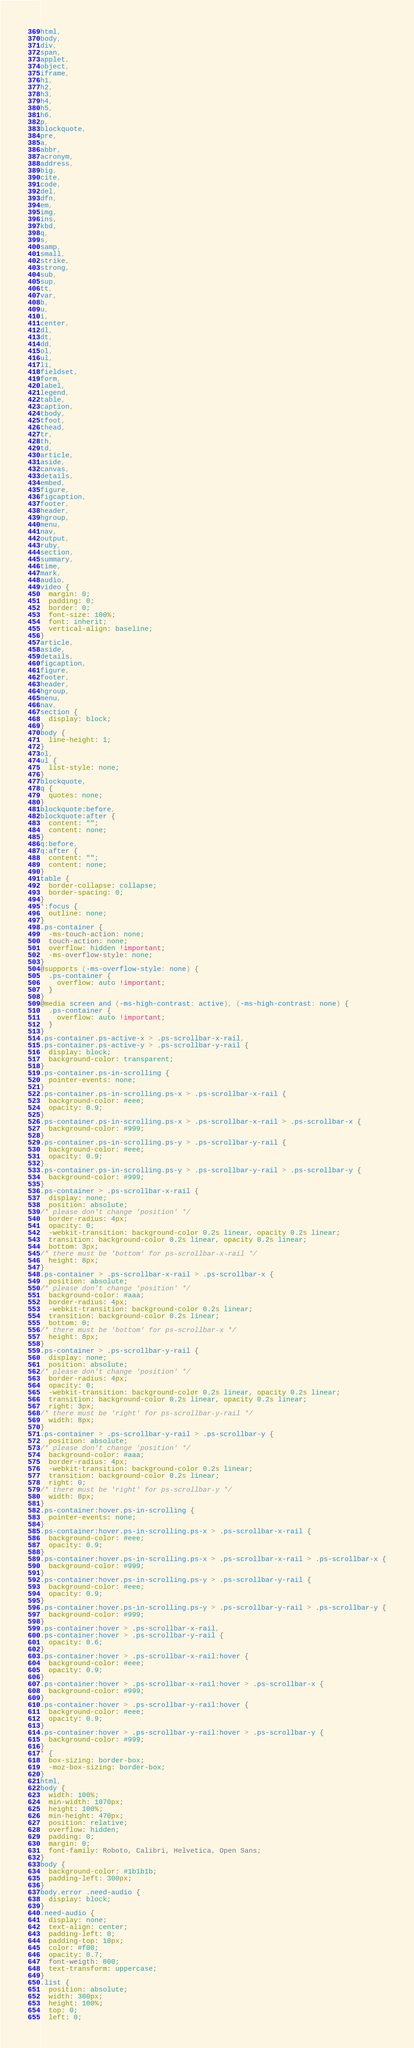Convert code to text. <code><loc_0><loc_0><loc_500><loc_500><_CSS_>html,
body,
div,
span,
applet,
object,
iframe,
h1,
h2,
h3,
h4,
h5,
h6,
p,
blockquote,
pre,
a,
abbr,
acronym,
address,
big,
cite,
code,
del,
dfn,
em,
img,
ins,
kbd,
q,
s,
samp,
small,
strike,
strong,
sub,
sup,
tt,
var,
b,
u,
i,
center,
dl,
dt,
dd,
ol,
ul,
li,
fieldset,
form,
label,
legend,
table,
caption,
tbody,
tfoot,
thead,
tr,
th,
td,
article,
aside,
canvas,
details,
embed,
figure,
figcaption,
footer,
header,
hgroup,
menu,
nav,
output,
ruby,
section,
summary,
time,
mark,
audio,
video {
  margin: 0;
  padding: 0;
  border: 0;
  font-size: 100%;
  font: inherit;
  vertical-align: baseline;
}
article,
aside,
details,
figcaption,
figure,
footer,
header,
hgroup,
menu,
nav,
section {
  display: block;
}
body {
  line-height: 1;
}
ol,
ul {
  list-style: none;
}
blockquote,
q {
  quotes: none;
}
blockquote:before,
blockquote:after {
  content: "";
  content: none;
}
q:before,
q:after {
  content: "";
  content: none;
}
table {
  border-collapse: collapse;
  border-spacing: 0;
}
*:focus {
  outline: none;
}
.ps-container {
  -ms-touch-action: none;
  touch-action: none;
  overflow: hidden !important;
  -ms-overflow-style: none;
}
@supports (-ms-overflow-style: none) {
  .ps-container {
    overflow: auto !important;
  }
}
@media screen and (-ms-high-contrast: active), (-ms-high-contrast: none) {
  .ps-container {
    overflow: auto !important;
  }
}
.ps-container.ps-active-x > .ps-scrollbar-x-rail,
.ps-container.ps-active-y > .ps-scrollbar-y-rail {
  display: block;
  background-color: transparent;
}
.ps-container.ps-in-scrolling {
  pointer-events: none;
}
.ps-container.ps-in-scrolling.ps-x > .ps-scrollbar-x-rail {
  background-color: #eee;
  opacity: 0.9;
}
.ps-container.ps-in-scrolling.ps-x > .ps-scrollbar-x-rail > .ps-scrollbar-x {
  background-color: #999;
}
.ps-container.ps-in-scrolling.ps-y > .ps-scrollbar-y-rail {
  background-color: #eee;
  opacity: 0.9;
}
.ps-container.ps-in-scrolling.ps-y > .ps-scrollbar-y-rail > .ps-scrollbar-y {
  background-color: #999;
}
.ps-container > .ps-scrollbar-x-rail {
  display: none;
  position: absolute;
/* please don't change 'position' */
  border-radius: 4px;
  opacity: 0;
  -webkit-transition: background-color 0.2s linear, opacity 0.2s linear;
  transition: background-color 0.2s linear, opacity 0.2s linear;
  bottom: 3px;
/* there must be 'bottom' for ps-scrollbar-x-rail */
  height: 8px;
}
.ps-container > .ps-scrollbar-x-rail > .ps-scrollbar-x {
  position: absolute;
/* please don't change 'position' */
  background-color: #aaa;
  border-radius: 4px;
  -webkit-transition: background-color 0.2s linear;
  transition: background-color 0.2s linear;
  bottom: 0;
/* there must be 'bottom' for ps-scrollbar-x */
  height: 8px;
}
.ps-container > .ps-scrollbar-y-rail {
  display: none;
  position: absolute;
/* please don't change 'position' */
  border-radius: 4px;
  opacity: 0;
  -webkit-transition: background-color 0.2s linear, opacity 0.2s linear;
  transition: background-color 0.2s linear, opacity 0.2s linear;
  right: 3px;
/* there must be 'right' for ps-scrollbar-y-rail */
  width: 8px;
}
.ps-container > .ps-scrollbar-y-rail > .ps-scrollbar-y {
  position: absolute;
/* please don't change 'position' */
  background-color: #aaa;
  border-radius: 4px;
  -webkit-transition: background-color 0.2s linear;
  transition: background-color 0.2s linear;
  right: 0;
/* there must be 'right' for ps-scrollbar-y */
  width: 8px;
}
.ps-container:hover.ps-in-scrolling {
  pointer-events: none;
}
.ps-container:hover.ps-in-scrolling.ps-x > .ps-scrollbar-x-rail {
  background-color: #eee;
  opacity: 0.9;
}
.ps-container:hover.ps-in-scrolling.ps-x > .ps-scrollbar-x-rail > .ps-scrollbar-x {
  background-color: #999;
}
.ps-container:hover.ps-in-scrolling.ps-y > .ps-scrollbar-y-rail {
  background-color: #eee;
  opacity: 0.9;
}
.ps-container:hover.ps-in-scrolling.ps-y > .ps-scrollbar-y-rail > .ps-scrollbar-y {
  background-color: #999;
}
.ps-container:hover > .ps-scrollbar-x-rail,
.ps-container:hover > .ps-scrollbar-y-rail {
  opacity: 0.6;
}
.ps-container:hover > .ps-scrollbar-x-rail:hover {
  background-color: #eee;
  opacity: 0.9;
}
.ps-container:hover > .ps-scrollbar-x-rail:hover > .ps-scrollbar-x {
  background-color: #999;
}
.ps-container:hover > .ps-scrollbar-y-rail:hover {
  background-color: #eee;
  opacity: 0.9;
}
.ps-container:hover > .ps-scrollbar-y-rail:hover > .ps-scrollbar-y {
  background-color: #999;
}
* {
  box-sizing: border-box;
  -moz-box-sizing: border-box;
}
html,
body {
  width: 100%;
  min-width: 1070px;
  height: 100%;
  min-height: 470px;
  position: relative;
  overflow: hidden;
  padding: 0;
  margin: 0;
  font-family: Roboto, Calibri, Helvetica, Open Sans;
}
body {
  background-color: #1b1b1b;
  padding-left: 300px;
}
body.error .need-audio {
  display: block;
}
.need-audio {
  display: none;
  text-align: center;
  padding-left: 0;
  padding-top: 10px;
  color: #f00;
  opacity: 0.7;
  font-weigth: 800;
  text-transform: uppercase;
}
.list {
  position: absolute;
  width: 300px;
  height: 100%;
  top: 0;
  left: 0;</code> 